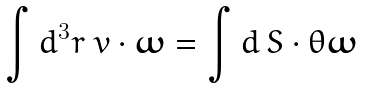Convert formula to latex. <formula><loc_0><loc_0><loc_500><loc_500>\int d ^ { 3 } r \ { v } \cdot { \boldsymbol \omega } = \int d \, { S } \cdot \theta { \boldsymbol \omega }</formula> 